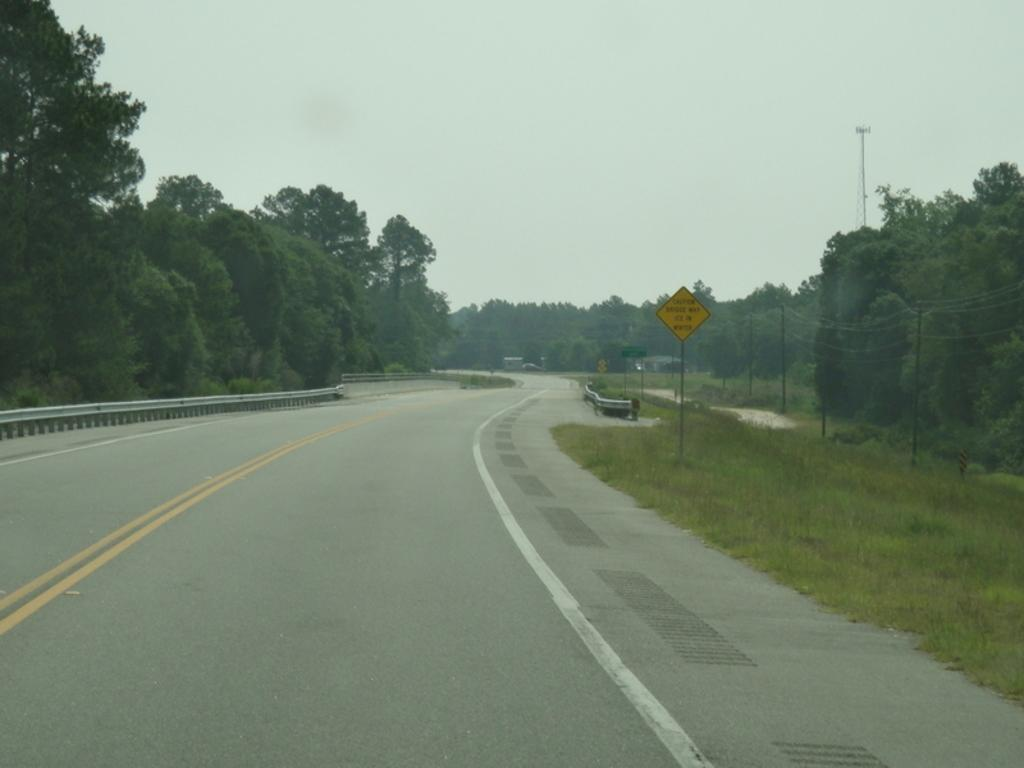What type of pathway is visible in the image? There is a road in the image. What type of barrier can be seen in the image? There is fencing in the image. What type of vegetation is present in the image? There are trees and grass in the image. What type of informational or directional device is present in the image? There is a sign board in the image. What type of vertical structures can be seen in the image? There are poles and a tower in the image. What part of the natural environment is visible in the image? The sky is visible in the image. How many boys are performing on the stage in the image? There is no stage or boys present in the image. What type of mark or blemish is visible on the grass in the image? There is no spot or mark visible on the grass in the image. 